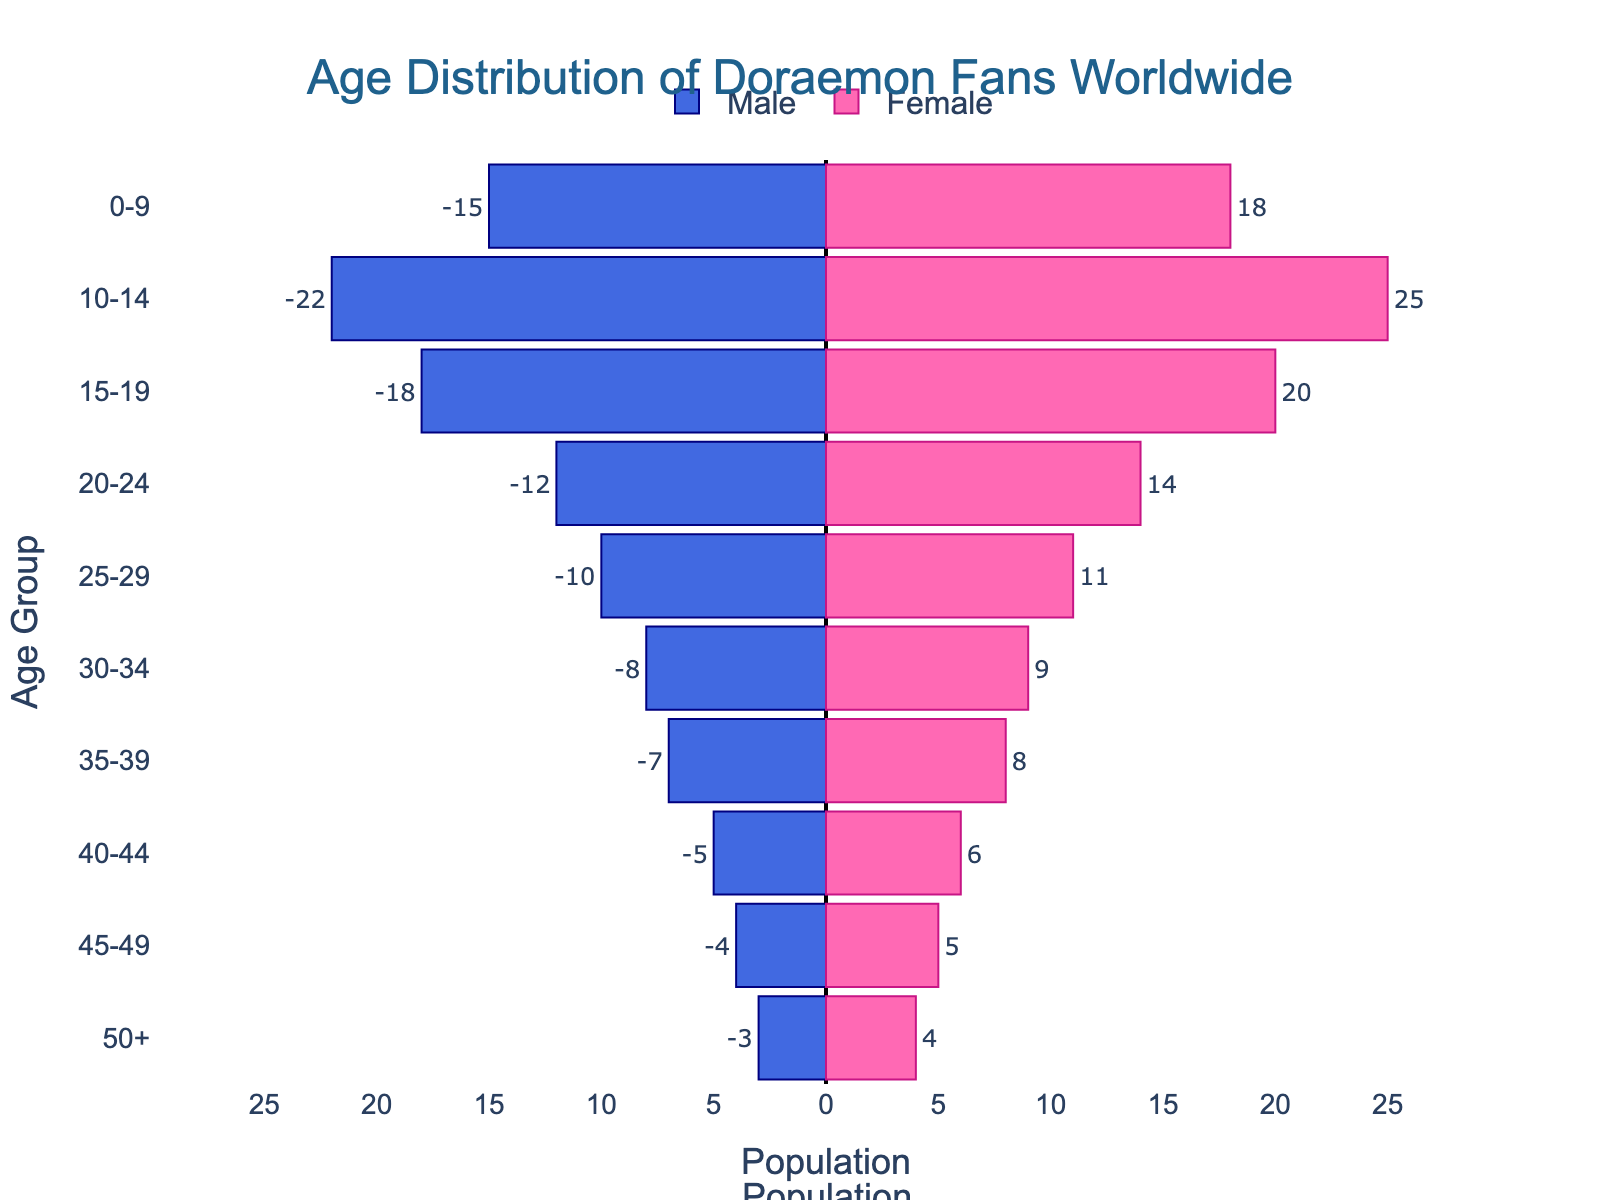Which age group has the highest number of female viewers? By inspecting the female bars in the pyramid, the longest bar corresponds to the age group 10-14. Thus, the age group 10-14 has the highest number of female viewers.
Answer: 10-14 Which age group has the smallest male population? By inspecting the male bars in the pyramid, the shortest bar corresponds to the age group 50+. Thus, the age group 50+ has the smallest male population.
Answer: 50+ What is the total number of male viewers in the age range 25-34? The male populations for the age groups 25-29 and 30-34 are 10 and 8, respectively. Summing these values gives 10 + 8 = 18.
Answer: 18 How does the male population in the age group 20-24 compare to the female population in the same age group? The male values for age group 20-24 is 12, while the female values are 14. The number of female viewers is greater than the number of male viewers by 2.
Answer: Female viewers > Male viewers What is the total population of fans in the age group 15-19? By summing the male and female populations in the age group 15-19, we get 18 + 20 = 38.
Answer: 38 Which age group shows the most balanced number of male and female viewers? By comparing the male and female bars in each age group, the age group 15-19 shows the closest numbers: 18 males and 20 females, indicating a more balanced distribution compared to other age groups.
Answer: 15-19 What is the average number of female viewers across all age groups? Sum all female values (18 + 25 + 20 + 14 + 11 + 9 + 8 + 6 + 5 + 4 = 120) and divide by the number of age groups (10), resulting in 120 / 10 = 12.
Answer: 12 Across which age groups does the female population exceed the male population by more than 10? By comparing each age group's male and female values, only the age group 10-14 has females (25) exceeding males (22) by more than 10.
Answer: None How many more fans are there in the age group 0-9 compared to the age group 50+? The total population for the age group 0-9 is 15 (male) + 18 (female)= 33, and for the age group 50+ is 3 (male) + 4 (female) = 7. The difference is 33 - 7 = 26.
Answer: 26 What is the ratio of male to female viewers in the age group 0-9? The male values for the age group 0-9 is 15, and the female values are 18. The ratio is 15/18 which simplifies to 5:6.
Answer: 5:6 